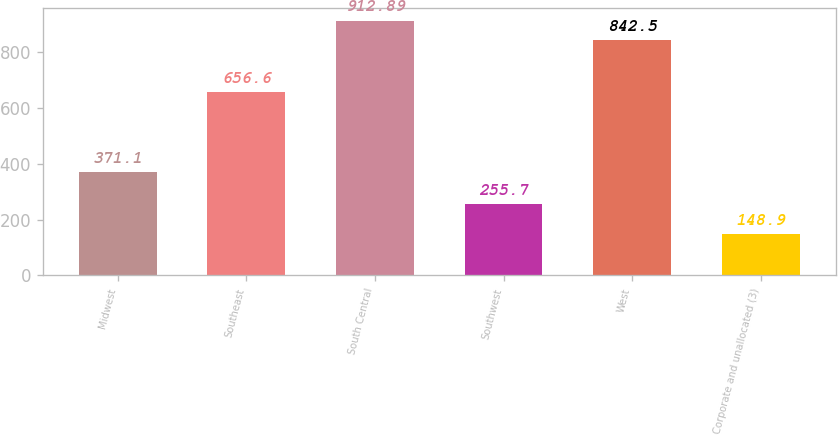Convert chart. <chart><loc_0><loc_0><loc_500><loc_500><bar_chart><fcel>Midwest<fcel>Southeast<fcel>South Central<fcel>Southwest<fcel>West<fcel>Corporate and unallocated (3)<nl><fcel>371.1<fcel>656.6<fcel>912.89<fcel>255.7<fcel>842.5<fcel>148.9<nl></chart> 